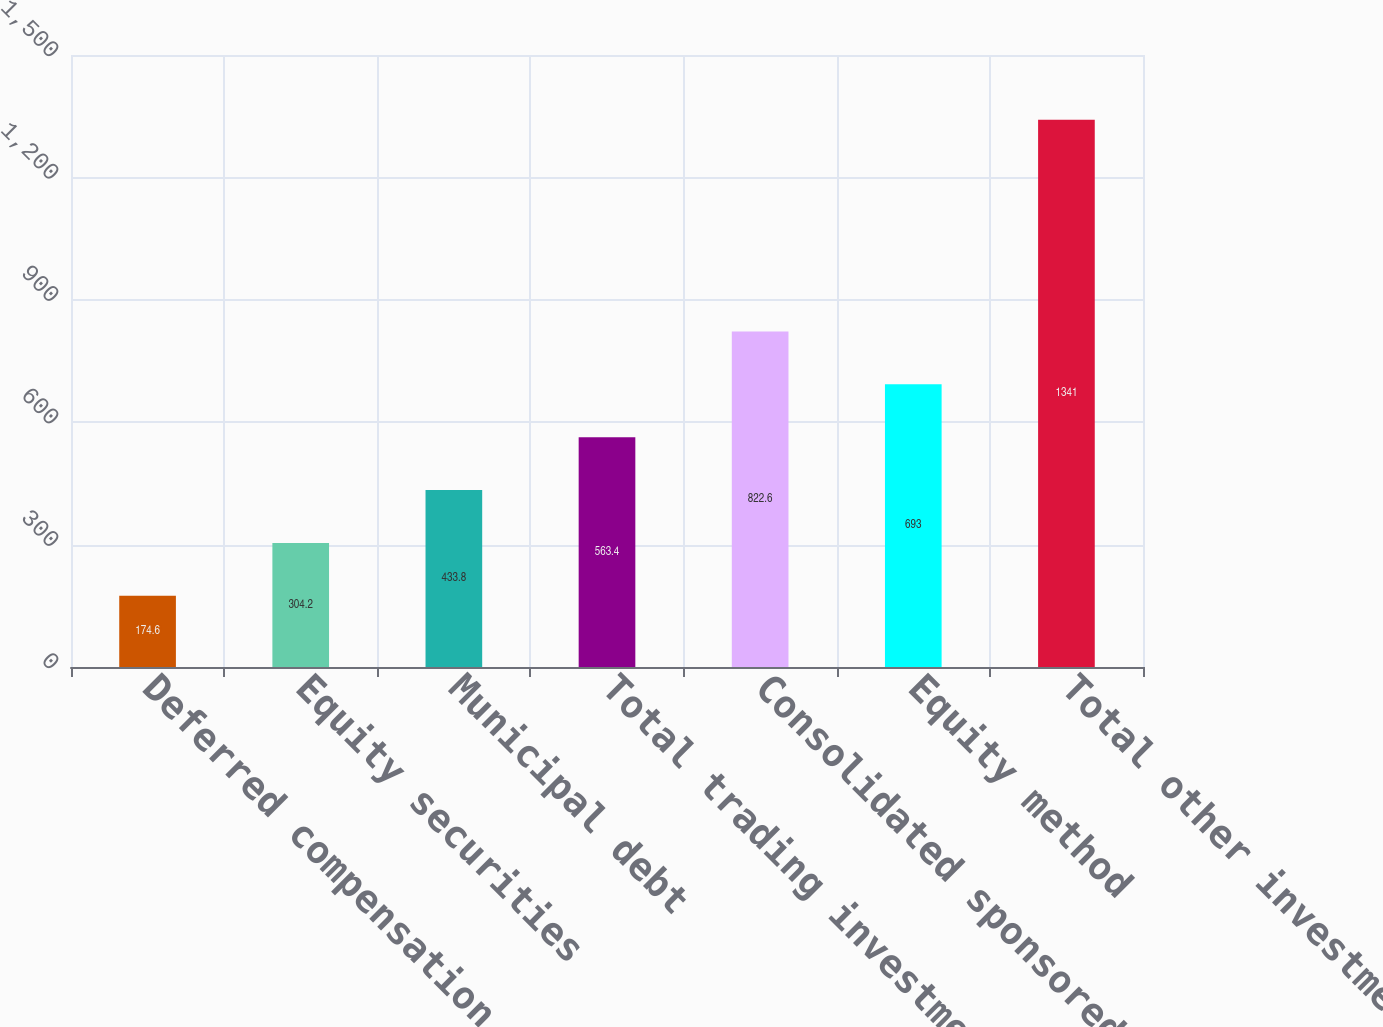Convert chart. <chart><loc_0><loc_0><loc_500><loc_500><bar_chart><fcel>Deferred compensation plan<fcel>Equity securities<fcel>Municipal debt<fcel>Total trading investments<fcel>Consolidated sponsored<fcel>Equity method<fcel>Total other investments<nl><fcel>174.6<fcel>304.2<fcel>433.8<fcel>563.4<fcel>822.6<fcel>693<fcel>1341<nl></chart> 